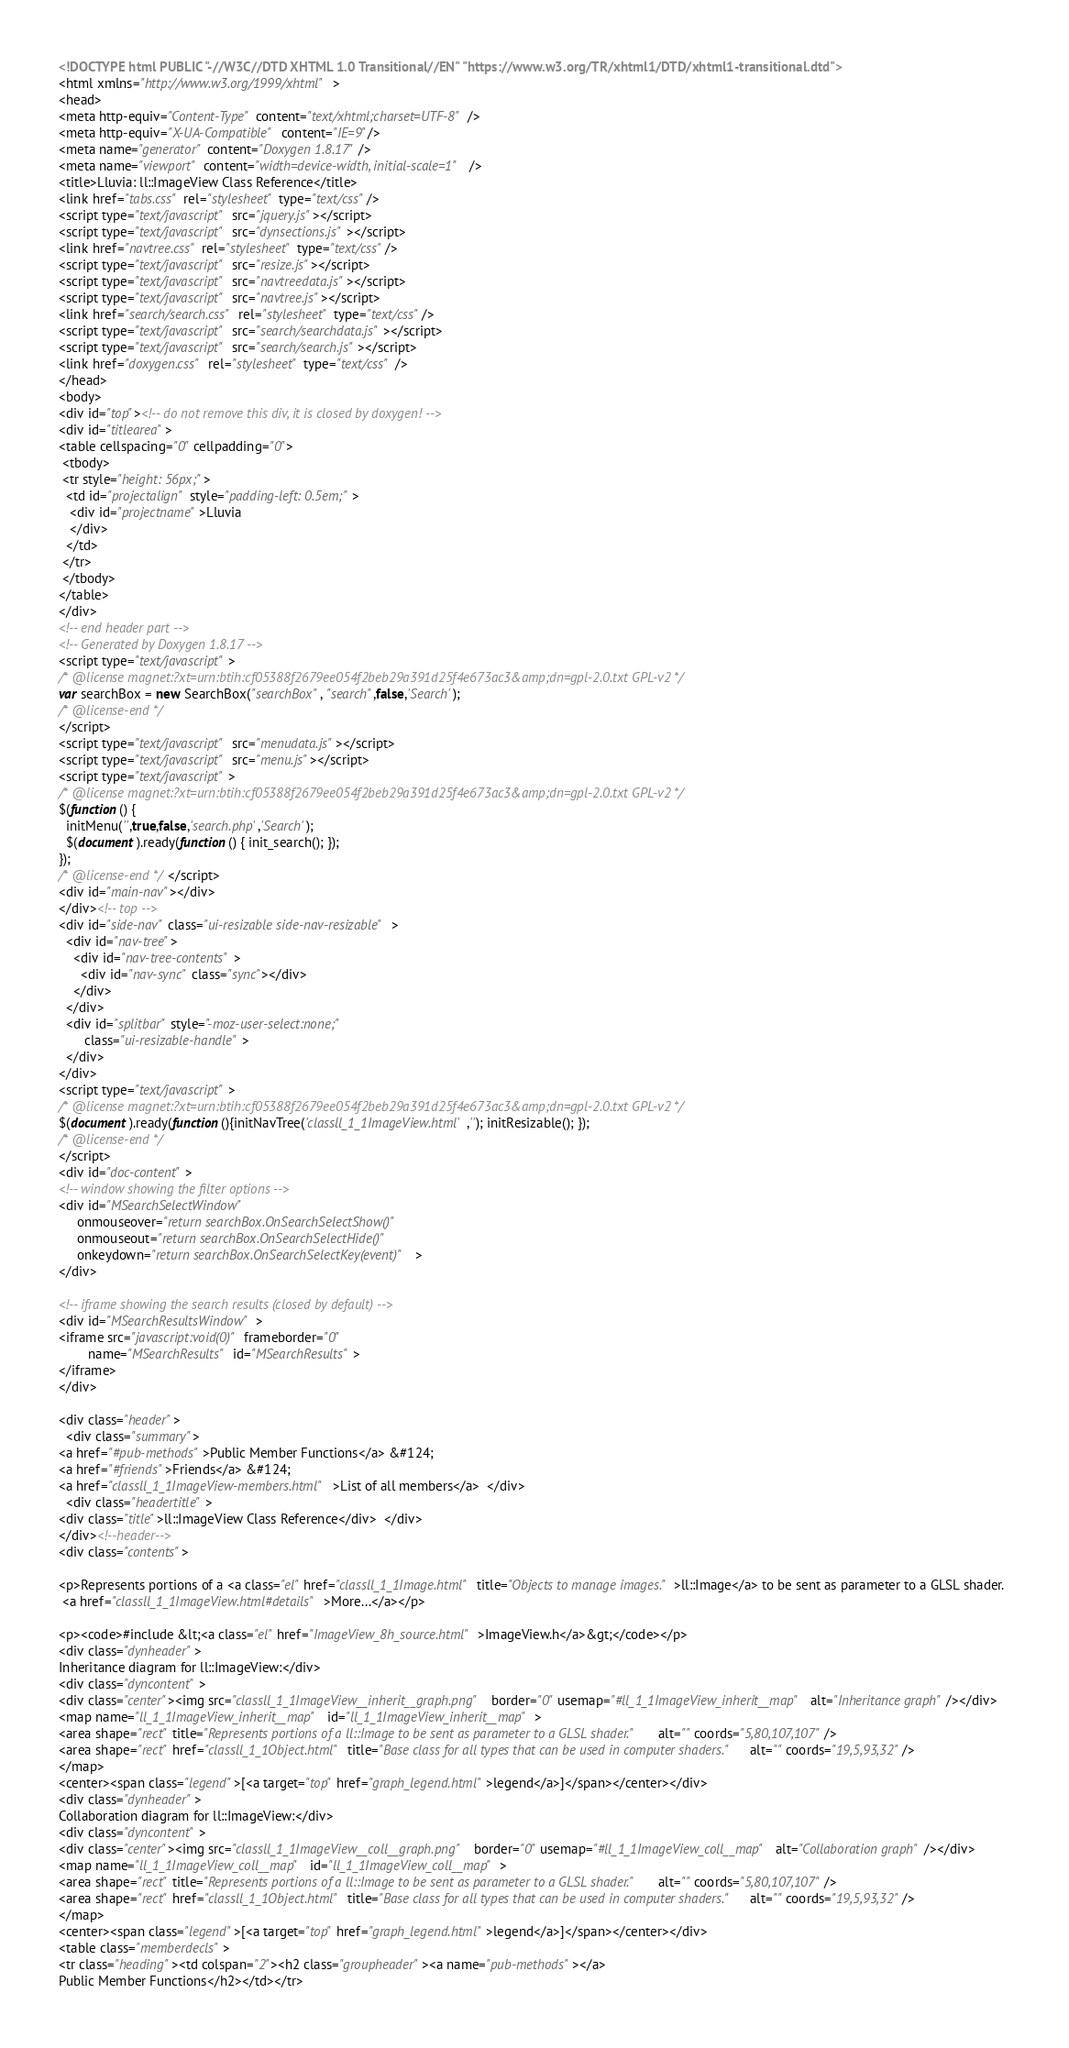Convert code to text. <code><loc_0><loc_0><loc_500><loc_500><_HTML_><!DOCTYPE html PUBLIC "-//W3C//DTD XHTML 1.0 Transitional//EN" "https://www.w3.org/TR/xhtml1/DTD/xhtml1-transitional.dtd">
<html xmlns="http://www.w3.org/1999/xhtml">
<head>
<meta http-equiv="Content-Type" content="text/xhtml;charset=UTF-8"/>
<meta http-equiv="X-UA-Compatible" content="IE=9"/>
<meta name="generator" content="Doxygen 1.8.17"/>
<meta name="viewport" content="width=device-width, initial-scale=1"/>
<title>Lluvia: ll::ImageView Class Reference</title>
<link href="tabs.css" rel="stylesheet" type="text/css"/>
<script type="text/javascript" src="jquery.js"></script>
<script type="text/javascript" src="dynsections.js"></script>
<link href="navtree.css" rel="stylesheet" type="text/css"/>
<script type="text/javascript" src="resize.js"></script>
<script type="text/javascript" src="navtreedata.js"></script>
<script type="text/javascript" src="navtree.js"></script>
<link href="search/search.css" rel="stylesheet" type="text/css"/>
<script type="text/javascript" src="search/searchdata.js"></script>
<script type="text/javascript" src="search/search.js"></script>
<link href="doxygen.css" rel="stylesheet" type="text/css" />
</head>
<body>
<div id="top"><!-- do not remove this div, it is closed by doxygen! -->
<div id="titlearea">
<table cellspacing="0" cellpadding="0">
 <tbody>
 <tr style="height: 56px;">
  <td id="projectalign" style="padding-left: 0.5em;">
   <div id="projectname">Lluvia
   </div>
  </td>
 </tr>
 </tbody>
</table>
</div>
<!-- end header part -->
<!-- Generated by Doxygen 1.8.17 -->
<script type="text/javascript">
/* @license magnet:?xt=urn:btih:cf05388f2679ee054f2beb29a391d25f4e673ac3&amp;dn=gpl-2.0.txt GPL-v2 */
var searchBox = new SearchBox("searchBox", "search",false,'Search');
/* @license-end */
</script>
<script type="text/javascript" src="menudata.js"></script>
<script type="text/javascript" src="menu.js"></script>
<script type="text/javascript">
/* @license magnet:?xt=urn:btih:cf05388f2679ee054f2beb29a391d25f4e673ac3&amp;dn=gpl-2.0.txt GPL-v2 */
$(function() {
  initMenu('',true,false,'search.php','Search');
  $(document).ready(function() { init_search(); });
});
/* @license-end */</script>
<div id="main-nav"></div>
</div><!-- top -->
<div id="side-nav" class="ui-resizable side-nav-resizable">
  <div id="nav-tree">
    <div id="nav-tree-contents">
      <div id="nav-sync" class="sync"></div>
    </div>
  </div>
  <div id="splitbar" style="-moz-user-select:none;" 
       class="ui-resizable-handle">
  </div>
</div>
<script type="text/javascript">
/* @license magnet:?xt=urn:btih:cf05388f2679ee054f2beb29a391d25f4e673ac3&amp;dn=gpl-2.0.txt GPL-v2 */
$(document).ready(function(){initNavTree('classll_1_1ImageView.html',''); initResizable(); });
/* @license-end */
</script>
<div id="doc-content">
<!-- window showing the filter options -->
<div id="MSearchSelectWindow"
     onmouseover="return searchBox.OnSearchSelectShow()"
     onmouseout="return searchBox.OnSearchSelectHide()"
     onkeydown="return searchBox.OnSearchSelectKey(event)">
</div>

<!-- iframe showing the search results (closed by default) -->
<div id="MSearchResultsWindow">
<iframe src="javascript:void(0)" frameborder="0" 
        name="MSearchResults" id="MSearchResults">
</iframe>
</div>

<div class="header">
  <div class="summary">
<a href="#pub-methods">Public Member Functions</a> &#124;
<a href="#friends">Friends</a> &#124;
<a href="classll_1_1ImageView-members.html">List of all members</a>  </div>
  <div class="headertitle">
<div class="title">ll::ImageView Class Reference</div>  </div>
</div><!--header-->
<div class="contents">

<p>Represents portions of a <a class="el" href="classll_1_1Image.html" title="Objects to manage images.">ll::Image</a> to be sent as parameter to a GLSL shader.  
 <a href="classll_1_1ImageView.html#details">More...</a></p>

<p><code>#include &lt;<a class="el" href="ImageView_8h_source.html">ImageView.h</a>&gt;</code></p>
<div class="dynheader">
Inheritance diagram for ll::ImageView:</div>
<div class="dyncontent">
<div class="center"><img src="classll_1_1ImageView__inherit__graph.png" border="0" usemap="#ll_1_1ImageView_inherit__map" alt="Inheritance graph"/></div>
<map name="ll_1_1ImageView_inherit__map" id="ll_1_1ImageView_inherit__map">
<area shape="rect" title="Represents portions of a ll::Image to be sent as parameter to a GLSL shader." alt="" coords="5,80,107,107"/>
<area shape="rect" href="classll_1_1Object.html" title="Base class for all types that can be used in computer shaders." alt="" coords="19,5,93,32"/>
</map>
<center><span class="legend">[<a target="top" href="graph_legend.html">legend</a>]</span></center></div>
<div class="dynheader">
Collaboration diagram for ll::ImageView:</div>
<div class="dyncontent">
<div class="center"><img src="classll_1_1ImageView__coll__graph.png" border="0" usemap="#ll_1_1ImageView_coll__map" alt="Collaboration graph"/></div>
<map name="ll_1_1ImageView_coll__map" id="ll_1_1ImageView_coll__map">
<area shape="rect" title="Represents portions of a ll::Image to be sent as parameter to a GLSL shader." alt="" coords="5,80,107,107"/>
<area shape="rect" href="classll_1_1Object.html" title="Base class for all types that can be used in computer shaders." alt="" coords="19,5,93,32"/>
</map>
<center><span class="legend">[<a target="top" href="graph_legend.html">legend</a>]</span></center></div>
<table class="memberdecls">
<tr class="heading"><td colspan="2"><h2 class="groupheader"><a name="pub-methods"></a>
Public Member Functions</h2></td></tr></code> 